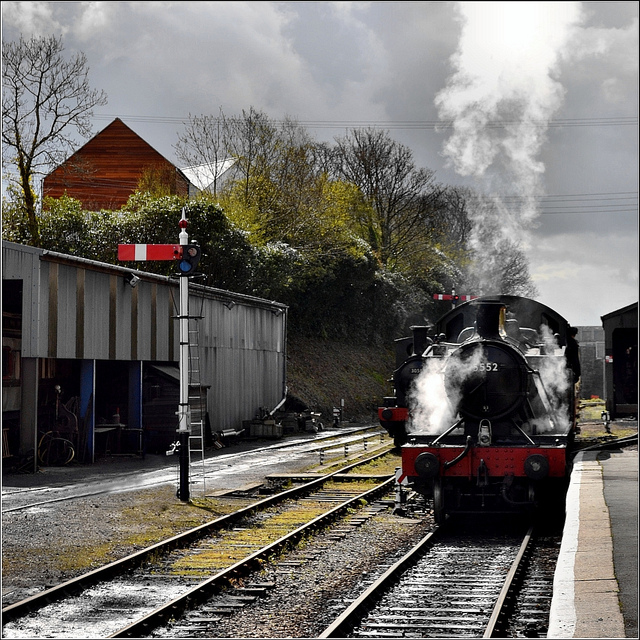<image>When was the first steam engine put into use? The exact date when the first steam engine was put into use is unknown. It can range from 1551 to the 1800s. When was the first steam engine put into use? I don't know when the first steam engine was put into use. It can be any of the mentioned years. 